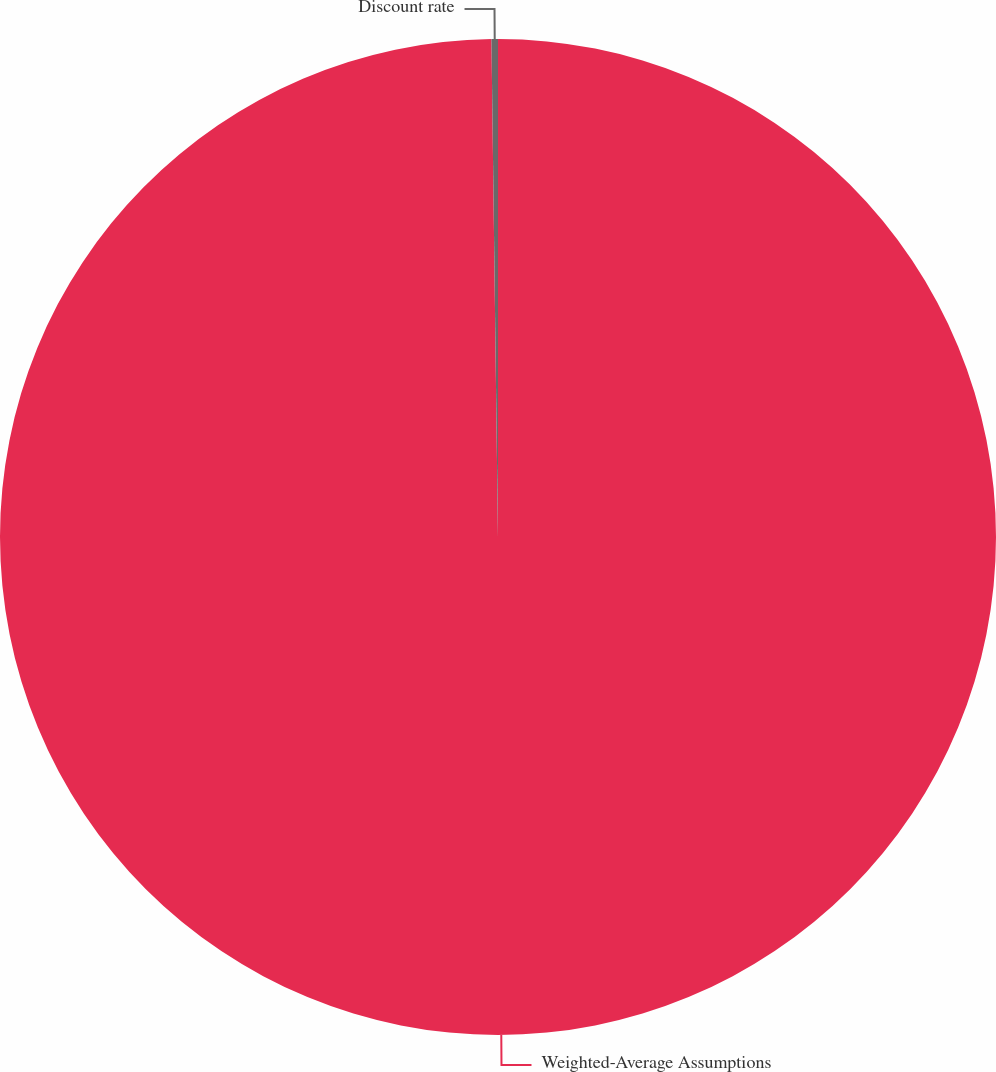Convert chart to OTSL. <chart><loc_0><loc_0><loc_500><loc_500><pie_chart><fcel>Weighted-Average Assumptions<fcel>Discount rate<nl><fcel>99.79%<fcel>0.21%<nl></chart> 